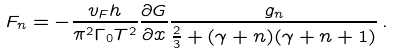<formula> <loc_0><loc_0><loc_500><loc_500>F _ { n } = - \frac { v _ { F } h } { \pi ^ { 2 } \Gamma _ { 0 } T ^ { 2 } } \frac { \partial G } { \partial x } \frac { g _ { n } } { \frac { 2 } { 3 } + ( \gamma + n ) ( \gamma + n + 1 ) } \, .</formula> 